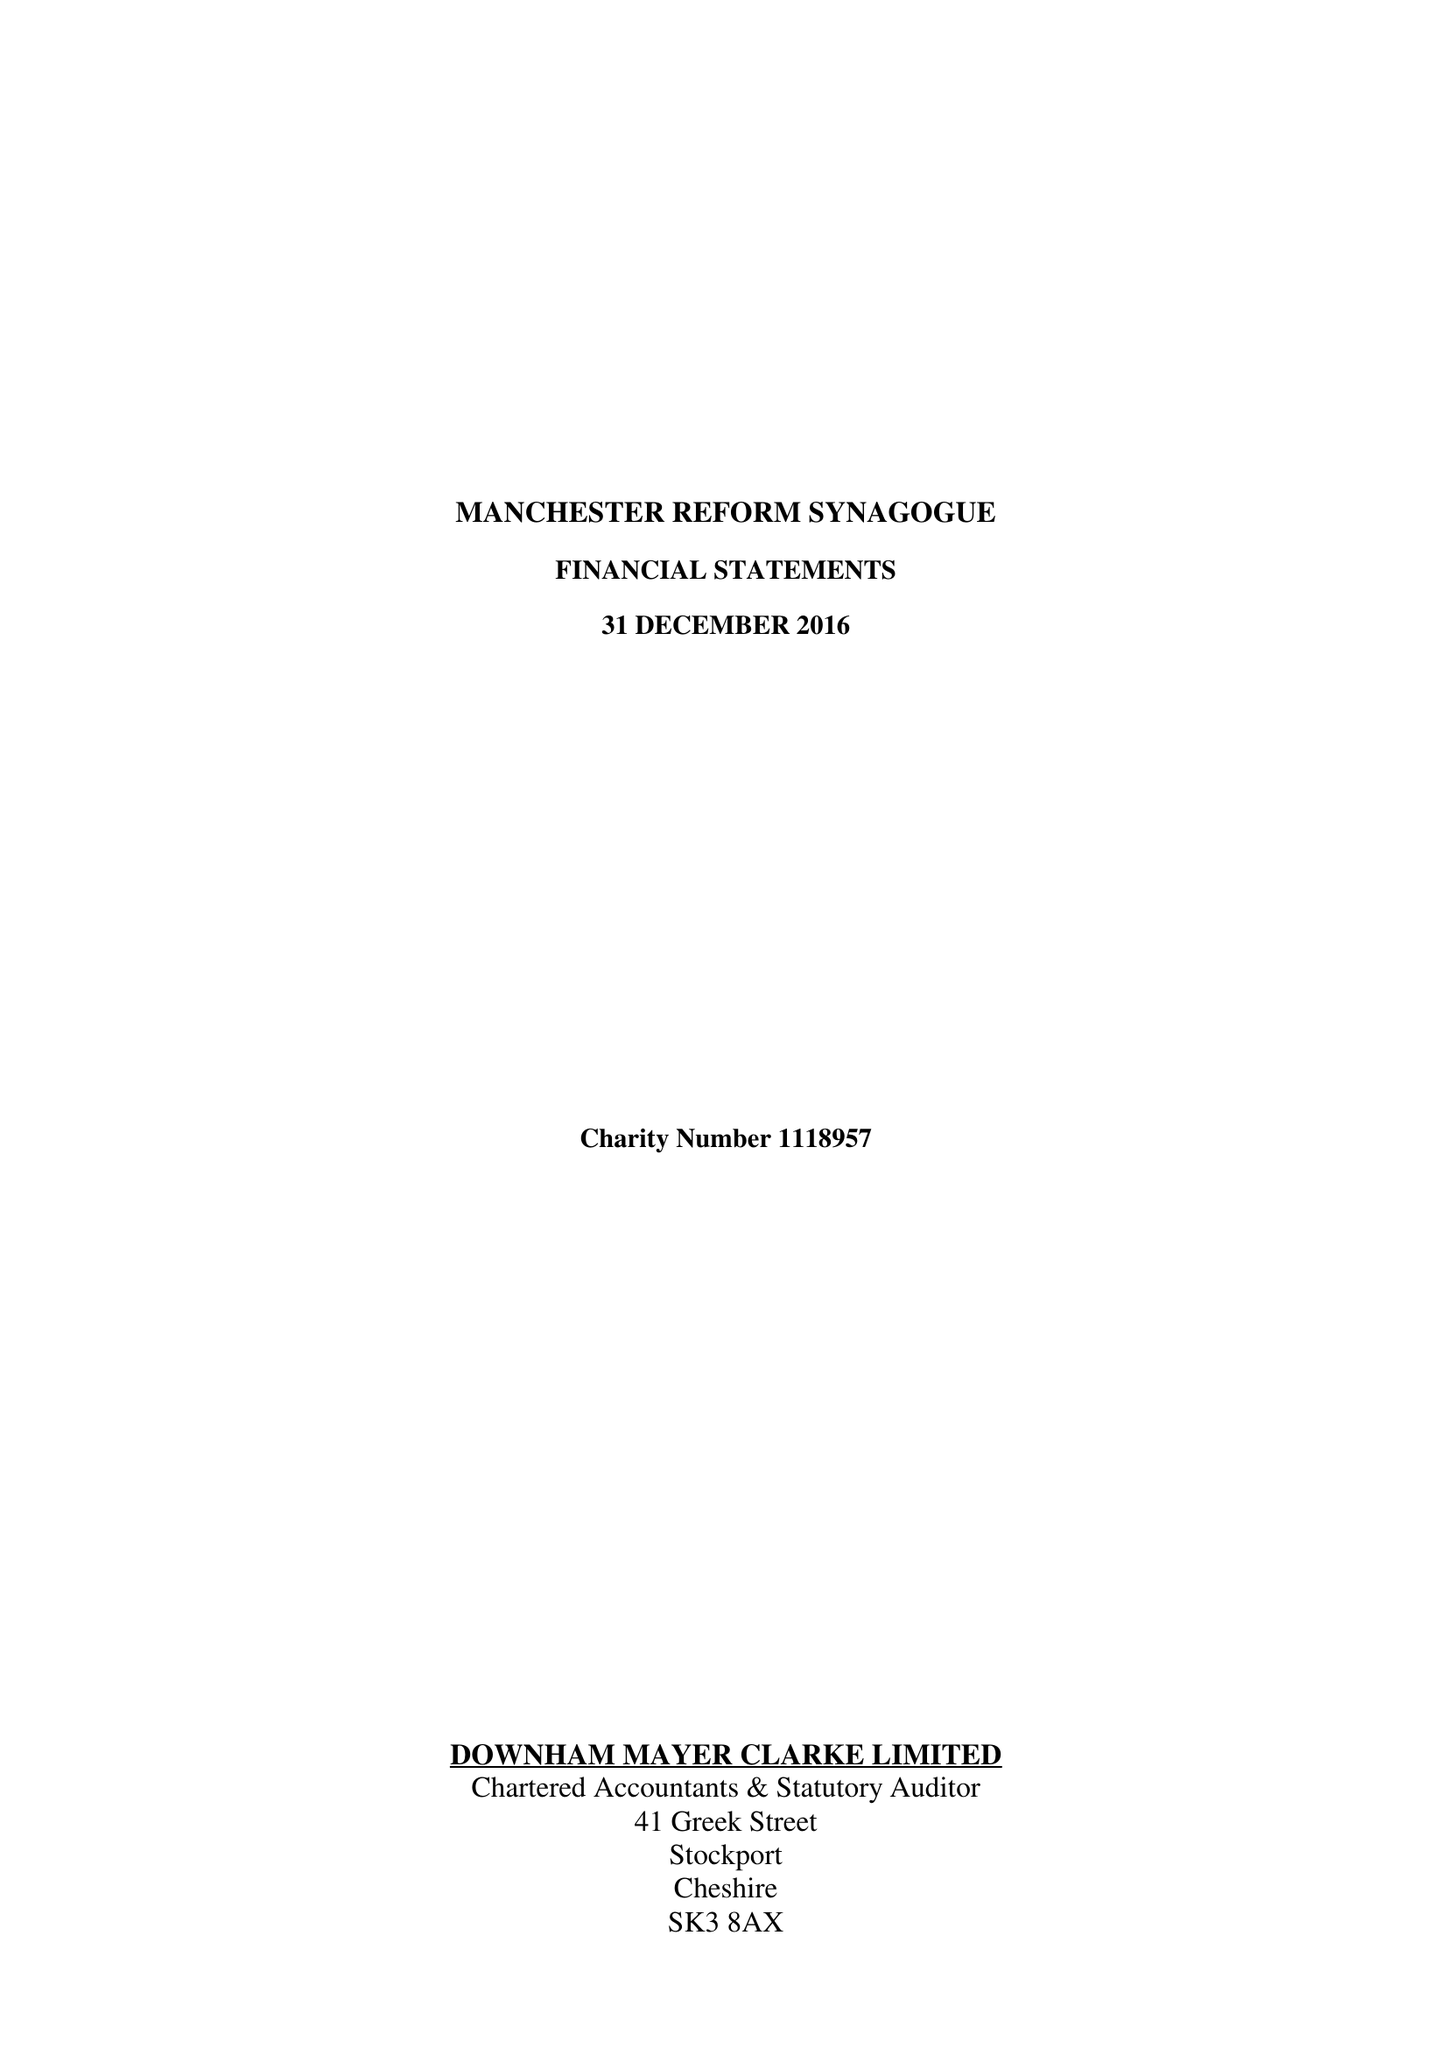What is the value for the address__street_line?
Answer the question using a single word or phrase. None 